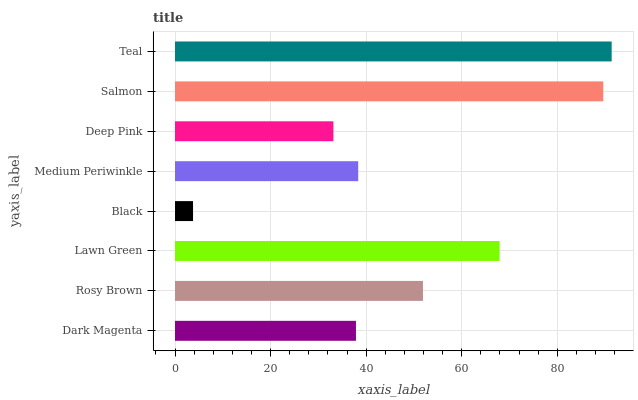Is Black the minimum?
Answer yes or no. Yes. Is Teal the maximum?
Answer yes or no. Yes. Is Rosy Brown the minimum?
Answer yes or no. No. Is Rosy Brown the maximum?
Answer yes or no. No. Is Rosy Brown greater than Dark Magenta?
Answer yes or no. Yes. Is Dark Magenta less than Rosy Brown?
Answer yes or no. Yes. Is Dark Magenta greater than Rosy Brown?
Answer yes or no. No. Is Rosy Brown less than Dark Magenta?
Answer yes or no. No. Is Rosy Brown the high median?
Answer yes or no. Yes. Is Medium Periwinkle the low median?
Answer yes or no. Yes. Is Deep Pink the high median?
Answer yes or no. No. Is Dark Magenta the low median?
Answer yes or no. No. 